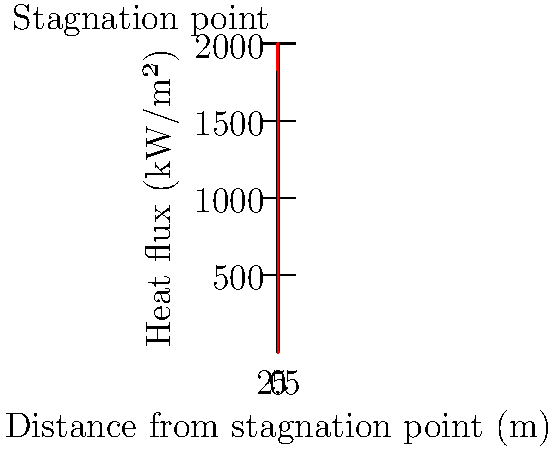Given the heat flux distribution on a spacecraft heat shield during re-entry as shown in the graph, what is the total heat load (in MJ/m²) experienced by a 1-meter wide strip of the heat shield from the stagnation point to 5 meters away, assuming the distribution remains constant for 100 seconds? To solve this problem, we need to follow these steps:

1) The heat flux distribution is given by the function:
   $q(x) = 2000e^{-0.5x^2}$ kW/m²

2) To find the total heat load, we need to integrate this function over the given distance and time:
   $Q = \int_0^5 \int_0^{100} q(x) dt dx$

3) Since the distribution remains constant, we can simplify this to:
   $Q = 100 \int_0^5 q(x) dx = 100 \int_0^5 2000e^{-0.5x^2} dx$

4) This integral doesn't have a simple analytical solution, so we need to use numerical integration. Using the trapezoidal rule with 1000 intervals:

   $Q \approx 100 \cdot 2000 \cdot 5 \cdot \frac{1}{1000} \sum_{i=0}^{999} \frac{1}{2}(e^{-0.5(i\Delta x)^2} + e^{-0.5((i+1)\Delta x)^2})$

   where $\Delta x = 5/1000 = 0.005$

5) Calculating this sum numerically (which can be done with a computer or calculator) gives approximately 316.94.

6) The units are still in kW·s/m², which we need to convert to MJ/m²:
   $316.94 \text{ kW·s/m²} \cdot \frac{1 \text{ MJ}}{1000 \text{ kJ}} = 0.31694 \text{ MJ/m²}$

Therefore, the total heat load is approximately 0.317 MJ/m².
Answer: 0.317 MJ/m² 